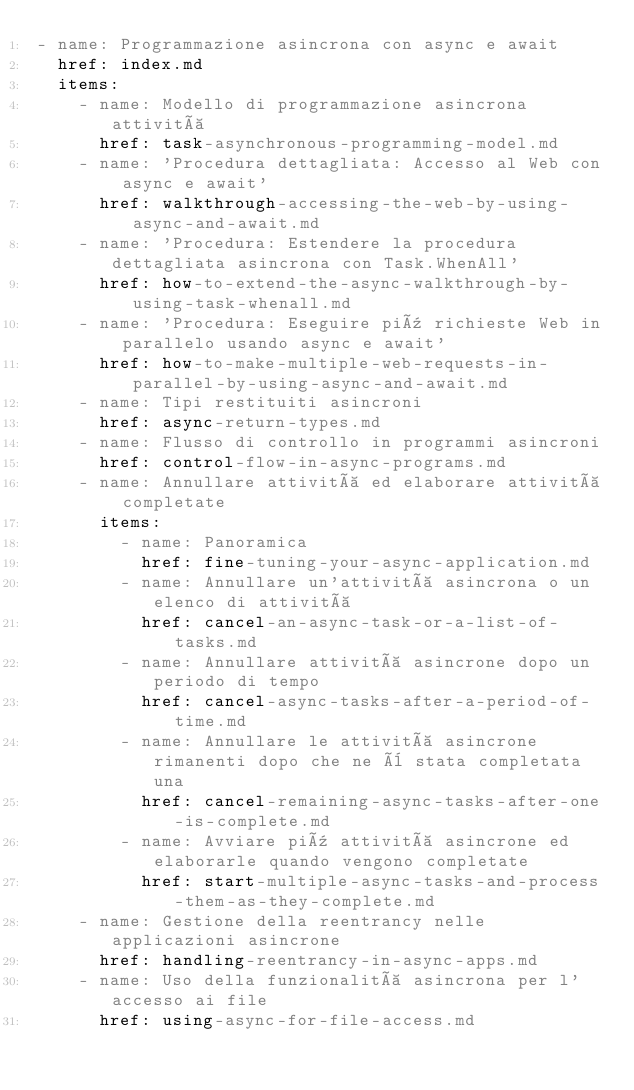Convert code to text. <code><loc_0><loc_0><loc_500><loc_500><_YAML_>- name: Programmazione asincrona con async e await
  href: index.md
  items:
    - name: Modello di programmazione asincrona attività
      href: task-asynchronous-programming-model.md
    - name: 'Procedura dettagliata: Accesso al Web con async e await'
      href: walkthrough-accessing-the-web-by-using-async-and-await.md
    - name: 'Procedura: Estendere la procedura dettagliata asincrona con Task.WhenAll'
      href: how-to-extend-the-async-walkthrough-by-using-task-whenall.md
    - name: 'Procedura: Eseguire più richieste Web in parallelo usando async e await'
      href: how-to-make-multiple-web-requests-in-parallel-by-using-async-and-await.md
    - name: Tipi restituiti asincroni
      href: async-return-types.md
    - name: Flusso di controllo in programmi asincroni
      href: control-flow-in-async-programs.md
    - name: Annullare attività ed elaborare attività completate
      items:
        - name: Panoramica
          href: fine-tuning-your-async-application.md
        - name: Annullare un'attività asincrona o un elenco di attività
          href: cancel-an-async-task-or-a-list-of-tasks.md
        - name: Annullare attività asincrone dopo un periodo di tempo
          href: cancel-async-tasks-after-a-period-of-time.md
        - name: Annullare le attività asincrone rimanenti dopo che ne è stata completata una
          href: cancel-remaining-async-tasks-after-one-is-complete.md
        - name: Avviare più attività asincrone ed elaborarle quando vengono completate
          href: start-multiple-async-tasks-and-process-them-as-they-complete.md
    - name: Gestione della reentrancy nelle applicazioni asincrone
      href: handling-reentrancy-in-async-apps.md
    - name: Uso della funzionalità asincrona per l'accesso ai file
      href: using-async-for-file-access.md</code> 